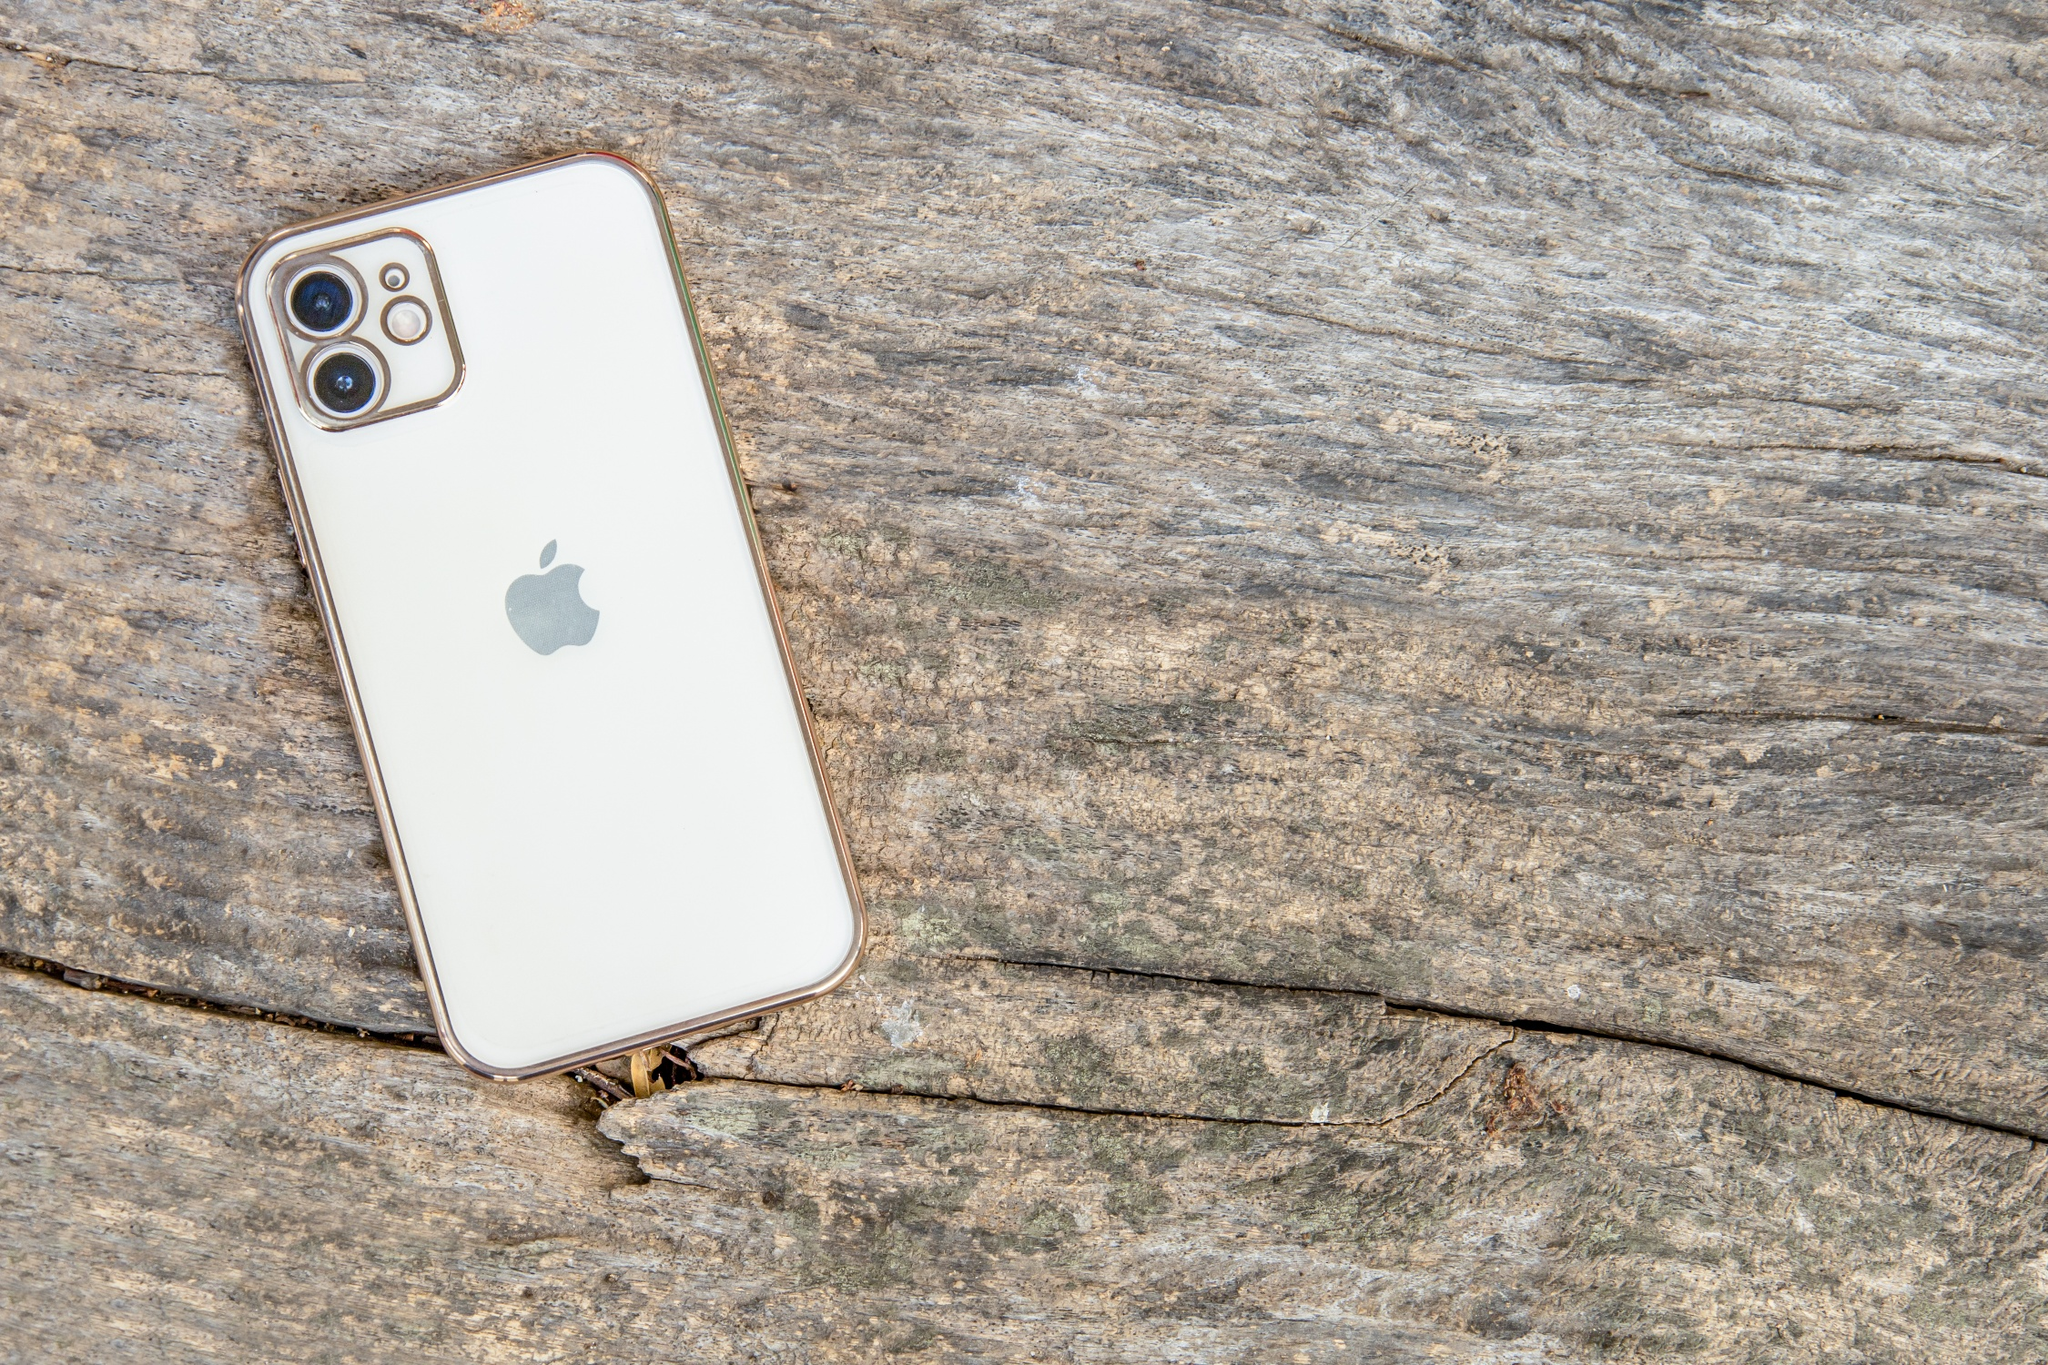Considering the surroundings, create a scenario where this iPhone could play a pivotal role. In a remote forest research station, a team of scientists was conducting a critical study on the effect of climate change on local flora. The area, known for its rich biodiversity, presented numerous challenges in terms of communication and data collection due to its isolation. Among the team was Dr. Alice, who relied heavily on her white iPhone for documenting their findings and staying in touch with the outside world via satellite connection. One evening, as the team gathered for dinner inside the wooden cabin, a sudden storm hit. The power went out, and their communication systems failed. Dr. Alice's iPhone, with its powerful battery and advanced satellite technology, became their sole link to safety. Using the phone, she quickly contacted emergency services and guided them to the exact location of the research station. The iPhone's durability had previously been tested by harsh environments, ensuring it still functioned under the extreme weather conditions. Its role was crucial, becoming the lifeline that enabled the rescue team to navigate the treacherous forest and ensure the safety of the scientists. How would the iPhone be useful in such a stormy condition in the forest? In the chaotic scenario of a storm hitting the remote forest research station, the iPhone's robust features would prove invaluable. Firstly, its high-resolution camera would allow Dr. Alice to document the storm’s effects on their surroundings, providing real-time data that could be crucial for weather analysis and future studies. The iPhone’s advanced satellite communication capabilities would enable her to send distress signals and real-time coordinates to the nearest rescue team, ensuring accurate and swift assistance. The device’s GPS navigation would help map a safe exit route while offering guidance through the dense forest. Furthermore, its weather-resistant build would ensure it remained operational despite exposure to rain and wind. The iPhone's flashlight feature could be utilized to signal for help in low visibility, and its emergency SOS functionality would send alerts to emergency contacts. Together, these features would make the iPhone an essential tool for survival and coordination in a dangerous, stormy environment. 